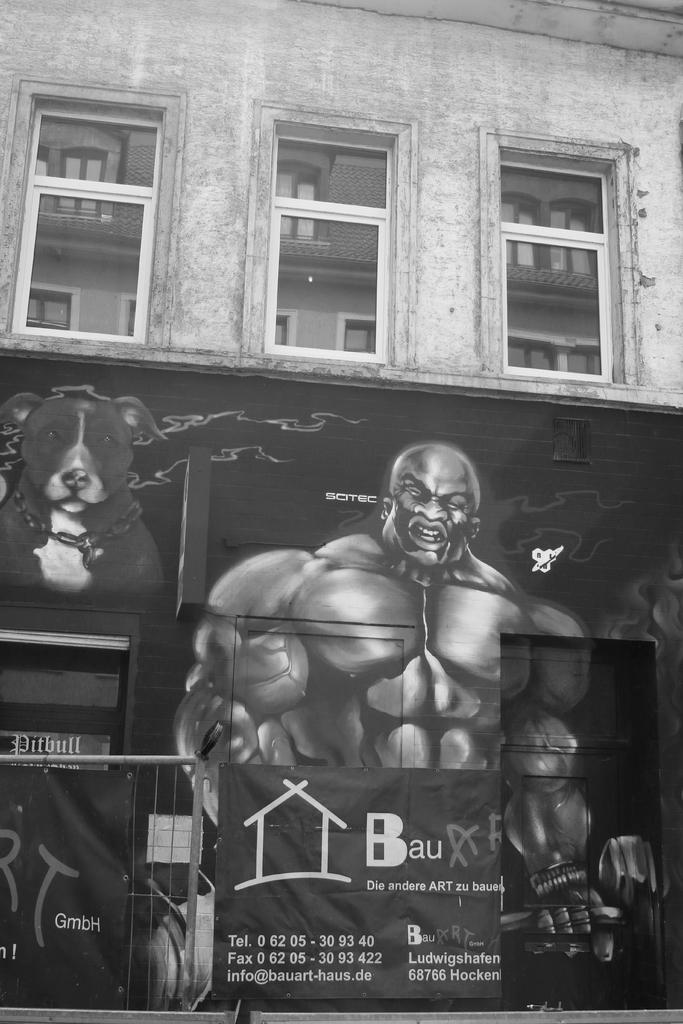What type of structure is visible in the image? There is a building in the image. What feature can be observed on the building? The building has windows. What artwork is present on the building? There is a painting of a person and a dog on the wall of the building. What is located in front of the building? There is a grill and banners in front of the building. What type of leather is used to make the boats in the image? There are no boats present in the image, so the type of leather used for them cannot be determined. 